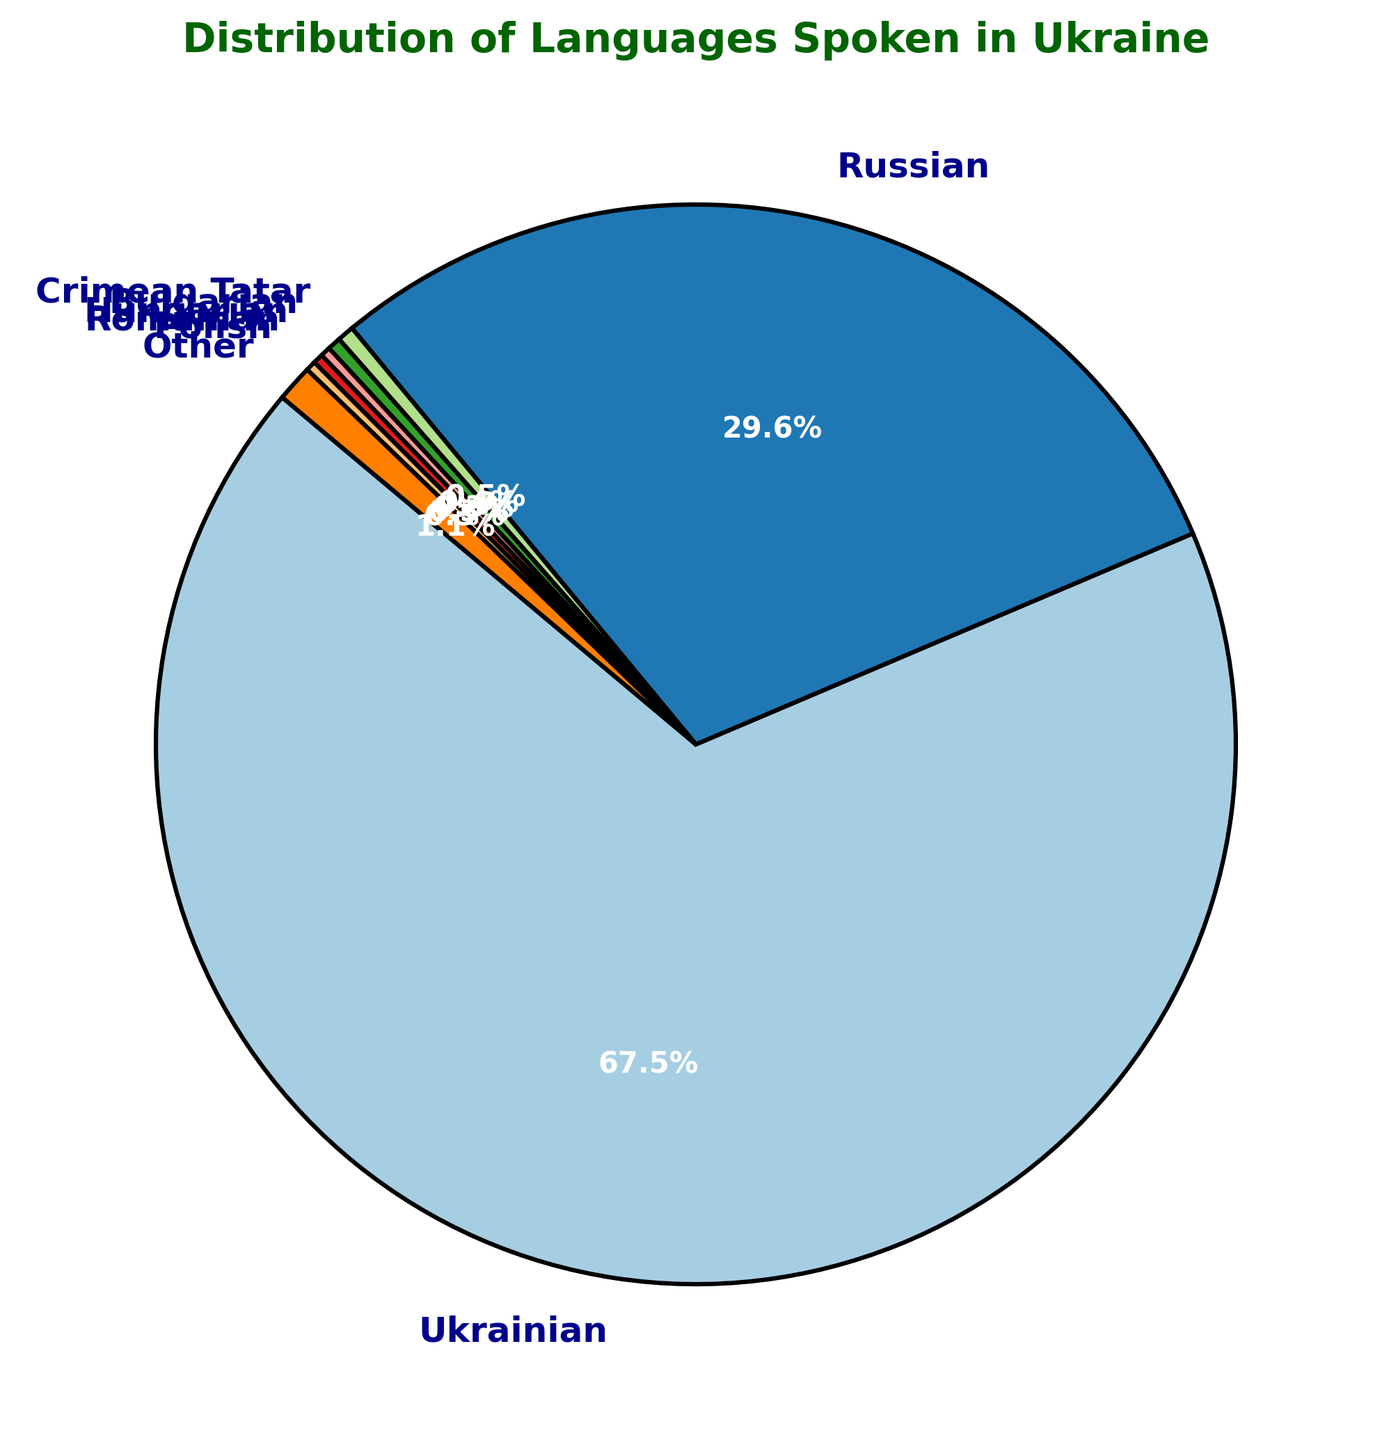What is the percentage of people speaking Ukrainian in Ukraine? The pie chart shows that the largest segment is labeled Ukrainian with a percentage of 67.5%.
Answer: 67.5% What is the combined percentage of people speaking Hungarian, Romanian, and Polish? Sum the individual percentages of Hungarian (0.3%), Romanian (0.3%), and Polish (0.3%), which is 0.3 + 0.3 + 0.3 = 0.9%.
Answer: 0.9% Which language is spoken by more people, Crimean Tatar or Bulgarian? Compare the percentages: Crimean Tatar (0.5%) and Bulgarian (0.4%). Since 0.5 is greater than 0.4, Crimean Tatar is spoken by more people.
Answer: Crimean Tatar Is the percentage of people who speak Russian greater than the sum of all other minority languages combined (Crimean Tatar, Bulgarian, Hungarian, Romanian, Polish, Other)? The sum of the minority languages: 0.5 + 0.4 + 0.3 + 0.3 + 0.3 + 1.1 = 2.9%. Comparing this to Russian (29.6%), 29.6% is indeed greater than 2.9%.
Answer: Yes How many languages have a percentage of speakers of 0.5% or lower? Identify languages with percentages of 0.5% or lower: Crimean Tatar (0.5%), Bulgarian (0.4%), Hungarian (0.3%), Romanian (0.3%), and Polish (0.3%). There are 5 such languages.
Answer: 5 Which language is the most spoken after Ukrainian and what is its percentage? The second-largest segment in the pie chart is labeled Russian with a percentage of 29.6%.
Answer: Russian (29.6%) What is the difference in percentage between people speaking Ukrainian and those speaking Russian? Subtract the percentage of Russian speakers (29.6%) from Ukrainian speakers (67.5%): 67.5 - 29.6 = 37.9%.
Answer: 37.9% What percentage of people speak languages other than Ukrainian and Russian? Subtract the combined percentage of Ukrainian and Russian speakers from 100%: 100 - (67.5 + 29.6) = 2.9%.
Answer: 2.9% What color represents the 'Other' languages on the pie chart? The color legend or the visual of the chart shows that 'Other' is represented by a distinct color in the pie chart; this specific color can be noted.
Answer: Identify based on the chart 